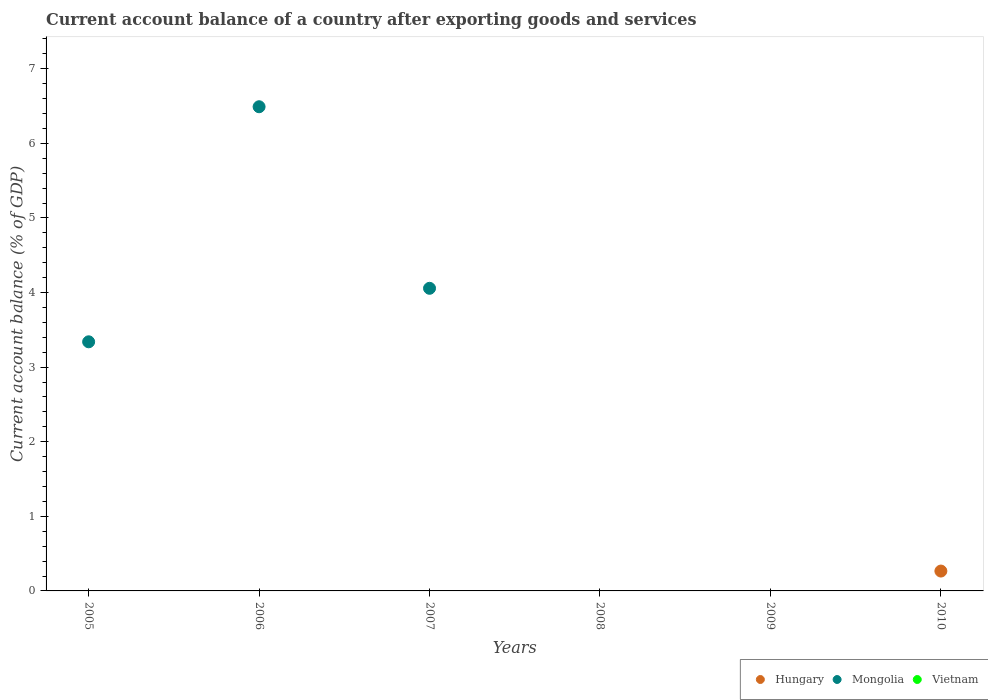How many different coloured dotlines are there?
Offer a very short reply. 2. What is the account balance in Mongolia in 2009?
Provide a short and direct response. 0. What is the total account balance in Mongolia in the graph?
Offer a very short reply. 13.89. What is the difference between the account balance in Mongolia in 2006 and the account balance in Hungary in 2009?
Provide a short and direct response. 6.49. What is the average account balance in Mongolia per year?
Provide a short and direct response. 2.31. What is the difference between the highest and the second highest account balance in Mongolia?
Give a very brief answer. 2.43. What is the difference between the highest and the lowest account balance in Mongolia?
Provide a succinct answer. 6.49. In how many years, is the account balance in Vietnam greater than the average account balance in Vietnam taken over all years?
Your answer should be compact. 0. Does the account balance in Hungary monotonically increase over the years?
Provide a succinct answer. No. Are the values on the major ticks of Y-axis written in scientific E-notation?
Keep it short and to the point. No. Does the graph contain any zero values?
Your response must be concise. Yes. What is the title of the graph?
Offer a very short reply. Current account balance of a country after exporting goods and services. Does "Congo (Democratic)" appear as one of the legend labels in the graph?
Your answer should be very brief. No. What is the label or title of the Y-axis?
Offer a very short reply. Current account balance (% of GDP). What is the Current account balance (% of GDP) of Hungary in 2005?
Ensure brevity in your answer.  0. What is the Current account balance (% of GDP) in Mongolia in 2005?
Provide a short and direct response. 3.34. What is the Current account balance (% of GDP) in Hungary in 2006?
Your response must be concise. 0. What is the Current account balance (% of GDP) in Mongolia in 2006?
Give a very brief answer. 6.49. What is the Current account balance (% of GDP) in Hungary in 2007?
Give a very brief answer. 0. What is the Current account balance (% of GDP) in Mongolia in 2007?
Keep it short and to the point. 4.06. What is the Current account balance (% of GDP) of Hungary in 2009?
Keep it short and to the point. 0. What is the Current account balance (% of GDP) in Vietnam in 2009?
Make the answer very short. 0. What is the Current account balance (% of GDP) of Hungary in 2010?
Your response must be concise. 0.27. Across all years, what is the maximum Current account balance (% of GDP) in Hungary?
Your response must be concise. 0.27. Across all years, what is the maximum Current account balance (% of GDP) in Mongolia?
Make the answer very short. 6.49. What is the total Current account balance (% of GDP) in Hungary in the graph?
Your answer should be very brief. 0.27. What is the total Current account balance (% of GDP) of Mongolia in the graph?
Provide a short and direct response. 13.89. What is the difference between the Current account balance (% of GDP) of Mongolia in 2005 and that in 2006?
Give a very brief answer. -3.15. What is the difference between the Current account balance (% of GDP) of Mongolia in 2005 and that in 2007?
Give a very brief answer. -0.72. What is the difference between the Current account balance (% of GDP) in Mongolia in 2006 and that in 2007?
Offer a terse response. 2.43. What is the average Current account balance (% of GDP) in Hungary per year?
Your answer should be compact. 0.04. What is the average Current account balance (% of GDP) in Mongolia per year?
Make the answer very short. 2.31. What is the ratio of the Current account balance (% of GDP) of Mongolia in 2005 to that in 2006?
Your answer should be very brief. 0.51. What is the ratio of the Current account balance (% of GDP) in Mongolia in 2005 to that in 2007?
Your answer should be compact. 0.82. What is the ratio of the Current account balance (% of GDP) of Mongolia in 2006 to that in 2007?
Offer a terse response. 1.6. What is the difference between the highest and the second highest Current account balance (% of GDP) in Mongolia?
Your answer should be compact. 2.43. What is the difference between the highest and the lowest Current account balance (% of GDP) in Hungary?
Your answer should be very brief. 0.27. What is the difference between the highest and the lowest Current account balance (% of GDP) of Mongolia?
Keep it short and to the point. 6.49. 